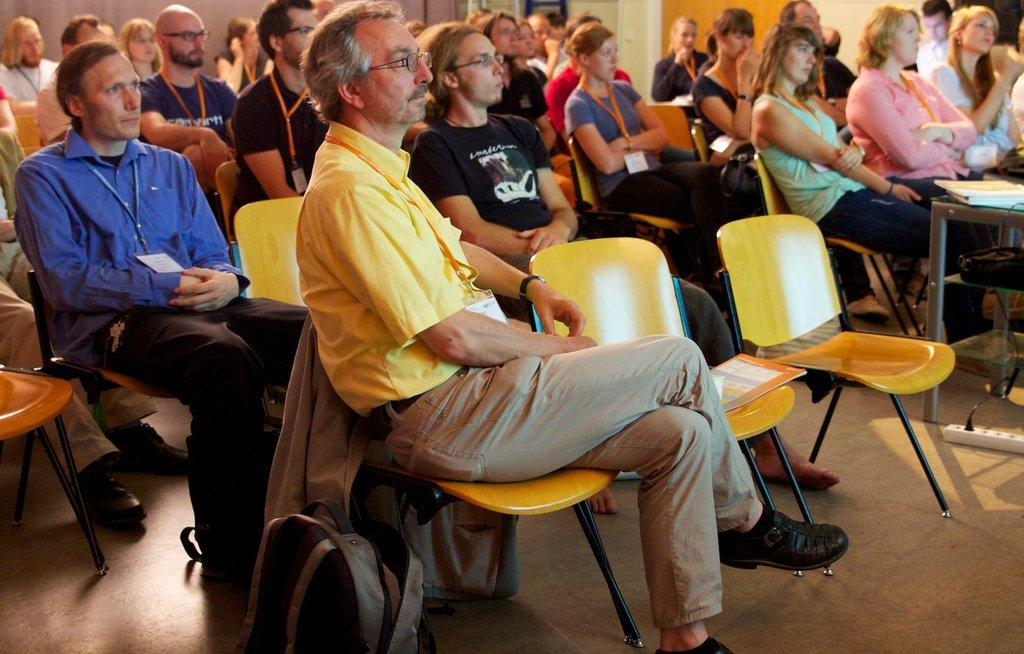How many people are in the image? There is a group of persons in the image. What are the persons in the image doing? The persons are sitting in a chair or chairs. What type of noise can be heard coming from the cook in the image? There is no cook present in the image, so it is not possible to determine what noise might be heard. 